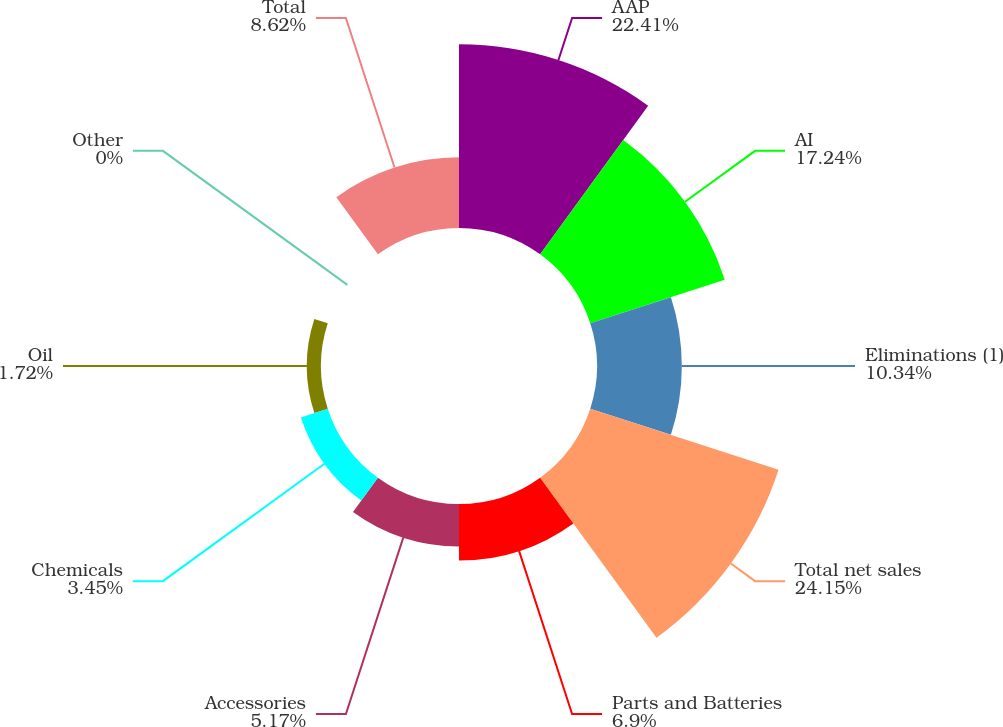Convert chart. <chart><loc_0><loc_0><loc_500><loc_500><pie_chart><fcel>AAP<fcel>AI<fcel>Eliminations (1)<fcel>Total net sales<fcel>Parts and Batteries<fcel>Accessories<fcel>Chemicals<fcel>Oil<fcel>Other<fcel>Total<nl><fcel>22.41%<fcel>17.24%<fcel>10.34%<fcel>24.14%<fcel>6.9%<fcel>5.17%<fcel>3.45%<fcel>1.72%<fcel>0.0%<fcel>8.62%<nl></chart> 